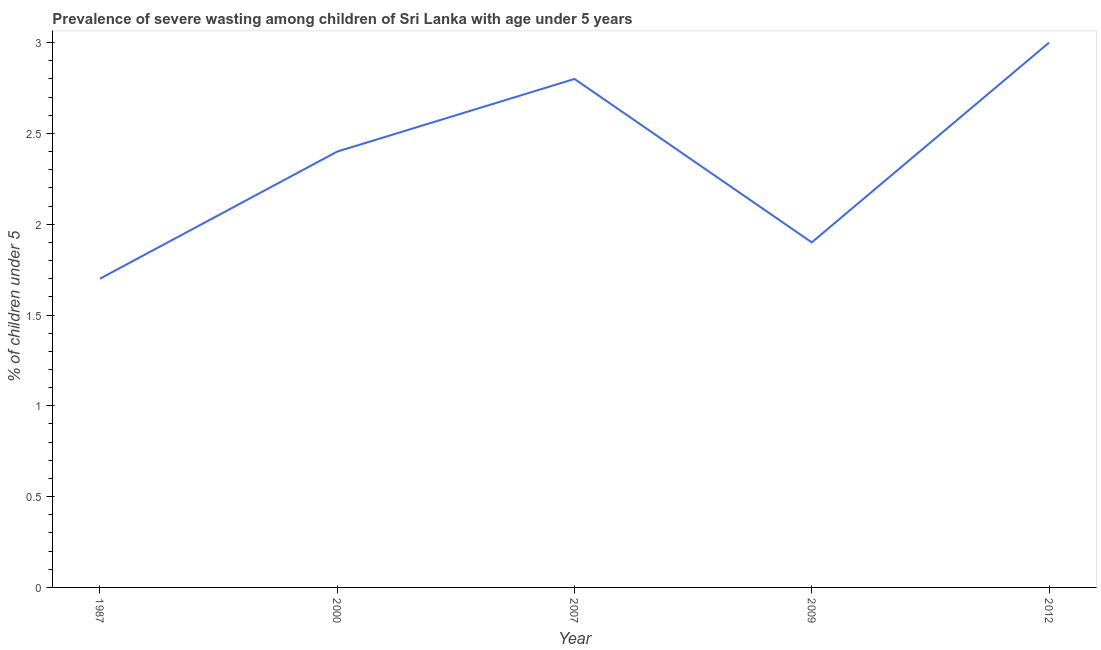What is the prevalence of severe wasting in 1987?
Keep it short and to the point. 1.7. Across all years, what is the maximum prevalence of severe wasting?
Make the answer very short. 3. Across all years, what is the minimum prevalence of severe wasting?
Offer a terse response. 1.7. In which year was the prevalence of severe wasting maximum?
Your answer should be very brief. 2012. What is the sum of the prevalence of severe wasting?
Provide a short and direct response. 11.8. What is the difference between the prevalence of severe wasting in 2007 and 2012?
Your answer should be very brief. -0.2. What is the average prevalence of severe wasting per year?
Your answer should be compact. 2.36. What is the median prevalence of severe wasting?
Provide a succinct answer. 2.4. Do a majority of the years between 2009 and 2012 (inclusive) have prevalence of severe wasting greater than 2 %?
Offer a very short reply. No. What is the ratio of the prevalence of severe wasting in 2000 to that in 2012?
Make the answer very short. 0.8. Is the difference between the prevalence of severe wasting in 2009 and 2012 greater than the difference between any two years?
Provide a short and direct response. No. What is the difference between the highest and the second highest prevalence of severe wasting?
Keep it short and to the point. 0.2. What is the difference between the highest and the lowest prevalence of severe wasting?
Offer a very short reply. 1.3. In how many years, is the prevalence of severe wasting greater than the average prevalence of severe wasting taken over all years?
Provide a short and direct response. 3. Does the prevalence of severe wasting monotonically increase over the years?
Provide a succinct answer. No. Are the values on the major ticks of Y-axis written in scientific E-notation?
Provide a short and direct response. No. What is the title of the graph?
Offer a very short reply. Prevalence of severe wasting among children of Sri Lanka with age under 5 years. What is the label or title of the X-axis?
Provide a short and direct response. Year. What is the label or title of the Y-axis?
Keep it short and to the point.  % of children under 5. What is the  % of children under 5 of 1987?
Your answer should be compact. 1.7. What is the  % of children under 5 in 2000?
Your response must be concise. 2.4. What is the  % of children under 5 in 2007?
Your answer should be very brief. 2.8. What is the  % of children under 5 of 2009?
Provide a short and direct response. 1.9. What is the  % of children under 5 of 2012?
Your response must be concise. 3. What is the difference between the  % of children under 5 in 1987 and 2007?
Give a very brief answer. -1.1. What is the difference between the  % of children under 5 in 1987 and 2009?
Offer a terse response. -0.2. What is the difference between the  % of children under 5 in 2000 and 2009?
Your answer should be compact. 0.5. What is the difference between the  % of children under 5 in 2007 and 2012?
Offer a terse response. -0.2. What is the difference between the  % of children under 5 in 2009 and 2012?
Your response must be concise. -1.1. What is the ratio of the  % of children under 5 in 1987 to that in 2000?
Offer a very short reply. 0.71. What is the ratio of the  % of children under 5 in 1987 to that in 2007?
Your answer should be compact. 0.61. What is the ratio of the  % of children under 5 in 1987 to that in 2009?
Keep it short and to the point. 0.9. What is the ratio of the  % of children under 5 in 1987 to that in 2012?
Provide a short and direct response. 0.57. What is the ratio of the  % of children under 5 in 2000 to that in 2007?
Offer a very short reply. 0.86. What is the ratio of the  % of children under 5 in 2000 to that in 2009?
Give a very brief answer. 1.26. What is the ratio of the  % of children under 5 in 2007 to that in 2009?
Your response must be concise. 1.47. What is the ratio of the  % of children under 5 in 2007 to that in 2012?
Keep it short and to the point. 0.93. What is the ratio of the  % of children under 5 in 2009 to that in 2012?
Give a very brief answer. 0.63. 